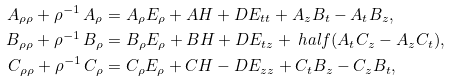Convert formula to latex. <formula><loc_0><loc_0><loc_500><loc_500>A _ { \rho \rho } + \rho ^ { - 1 } \, A _ { \rho } & = A _ { \rho } E _ { \rho } + A H + D E _ { t t } + A _ { z } B _ { t } - A _ { t } B _ { z } , \\ B _ { \rho \rho } + \rho ^ { - 1 } \, B _ { \rho } & = B _ { \rho } E _ { \rho } + B H + D E _ { t z } + \ h a l f ( A _ { t } C _ { z } - A _ { z } C _ { t } ) , \\ C _ { \rho \rho } + \rho ^ { - 1 } \, C _ { \rho } & = C _ { \rho } E _ { \rho } + C H - D E _ { z z } + C _ { t } B _ { z } - C _ { z } B _ { t } ,</formula> 